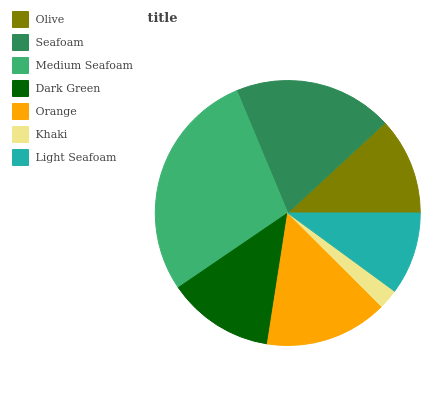Is Khaki the minimum?
Answer yes or no. Yes. Is Medium Seafoam the maximum?
Answer yes or no. Yes. Is Seafoam the minimum?
Answer yes or no. No. Is Seafoam the maximum?
Answer yes or no. No. Is Seafoam greater than Olive?
Answer yes or no. Yes. Is Olive less than Seafoam?
Answer yes or no. Yes. Is Olive greater than Seafoam?
Answer yes or no. No. Is Seafoam less than Olive?
Answer yes or no. No. Is Dark Green the high median?
Answer yes or no. Yes. Is Dark Green the low median?
Answer yes or no. Yes. Is Olive the high median?
Answer yes or no. No. Is Medium Seafoam the low median?
Answer yes or no. No. 